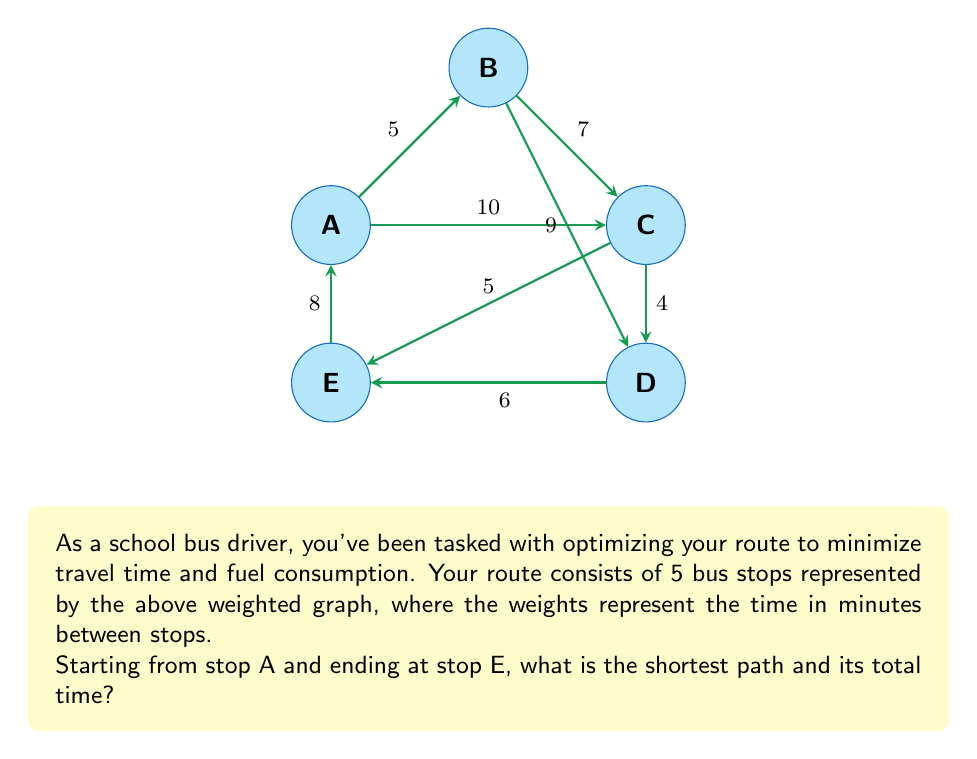Can you solve this math problem? To solve this problem, we can use Dijkstra's algorithm, which is an efficient method for finding the shortest path in a weighted graph.

Step 1: Initialize distances
Set the distance to A as 0 and all other distances as infinity.
$d(A) = 0$, $d(B) = d(C) = d(D) = d(E) = \infty$

Step 2: Visit vertices in order of shortest known distance
1. Start with A (distance 0)
   Update neighbors:
   $d(B) = \min(\infty, 0 + 5) = 5$
   $d(C) = \min(\infty, 0 + 10) = 10$
   $d(E) = \min(\infty, 0 + 8) = 8$

2. Visit B (distance 5)
   Update neighbors:
   $d(C) = \min(10, 5 + 7) = 10$
   $d(D) = \min(\infty, 5 + 9) = 14$

3. Visit E (distance 8)
   Update neighbors:
   $d(C) = \min(10, 8 + 5) = 10$
   $d(D) = \min(14, 8 + 6) = 14$

4. Visit C (distance 10)
   Update neighbors:
   $d(D) = \min(14, 10 + 4) = 14$

5. Visit D (distance 14, but no updates needed)

Step 3: Reconstruct the path
The shortest path from A to E is directly A to E.
Answer: The shortest path is A to E, with a total time of 8 minutes. 